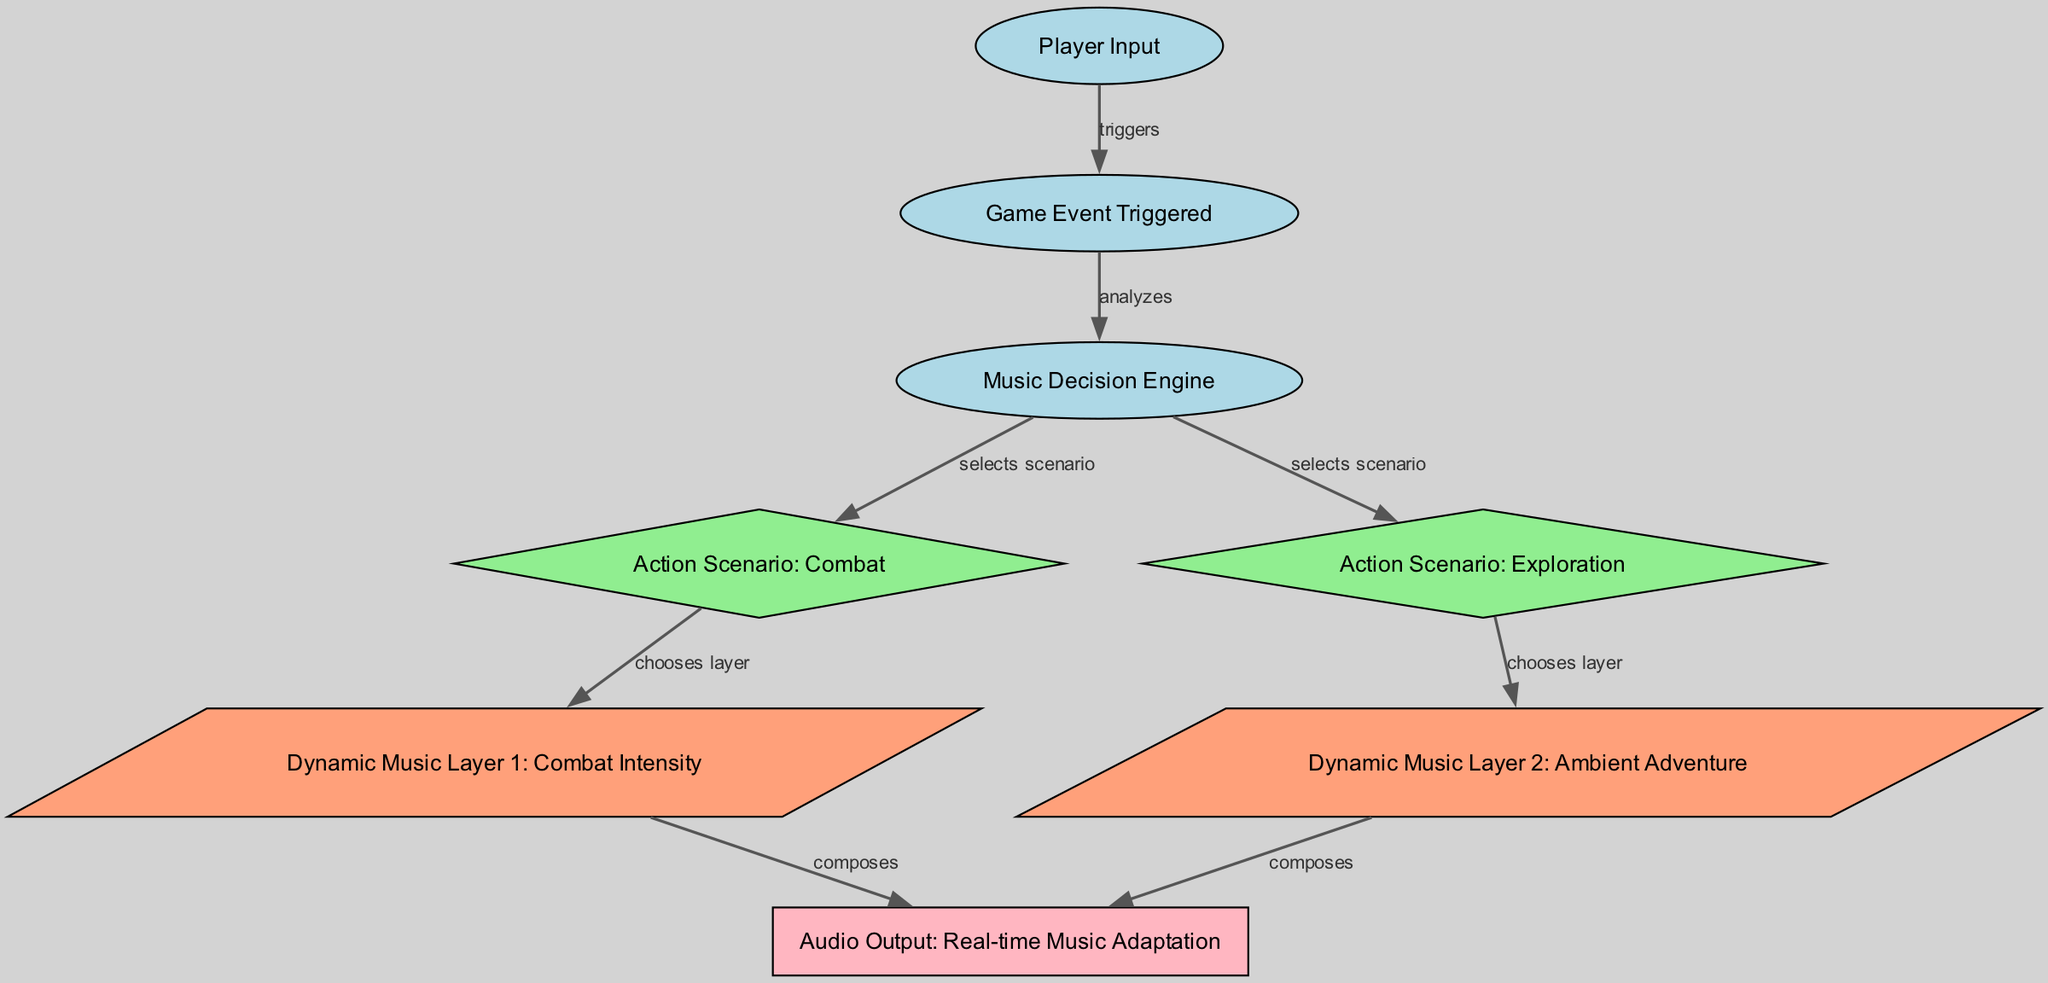What node initiates the process? The diagram starts with "Player Input," which is the first node and is responsible for triggering subsequent events in the flow.
Answer: Player Input How many action scenarios are represented in the diagram? There are two action scenarios indicated: "Combat" and "Exploration." Each scenario influences how music is selected and layered.
Answer: Two What type of node is "Music Decision Engine"? "Music Decision Engine" is categorized as an oval-shaped node, which reflects that it functions as a process that analyzes triggers from the player input.
Answer: Oval Which dynamic music layer corresponds to exploration? The dynamic music layer associated with exploration is labeled "Ambient Adventure," which is selected based on the scenario chosen by the music decision engine.
Answer: Ambient Adventure What is the final output of the process? The final output of the diagram is "Audio Output: Real-time Music Adaptation," which results from the compositions created from selected music layers based on player actions.
Answer: Audio Output: Real-time Music Adaptation How does the "Game Event Triggered" node relate to the "Music Decision Engine"? The "Game Event Triggered" node analyzes the input from the player and sends this data to the "Music Decision Engine," which decides how to adapt the music based on the event.
Answer: Analyzes Which layers are composed for the "Combat" scenario? The layer that is composed for the "Combat" scenario is "Combat Intensity." This layer adds dynamic music elements that increase based on the intensity of the combat actions performed by the player.
Answer: Combat Intensity What action does "Music Decision Engine" perform when selecting a scenario? The "Music Decision Engine" performs an analysis to decide which action scenario (either combat or exploration) to select based on the player's input and the game event triggered.
Answer: Selects scenario 